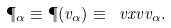<formula> <loc_0><loc_0><loc_500><loc_500>\P _ { \alpha } \equiv \P ( v _ { \alpha } ) \equiv \ v x v { v _ { \alpha } } .</formula> 